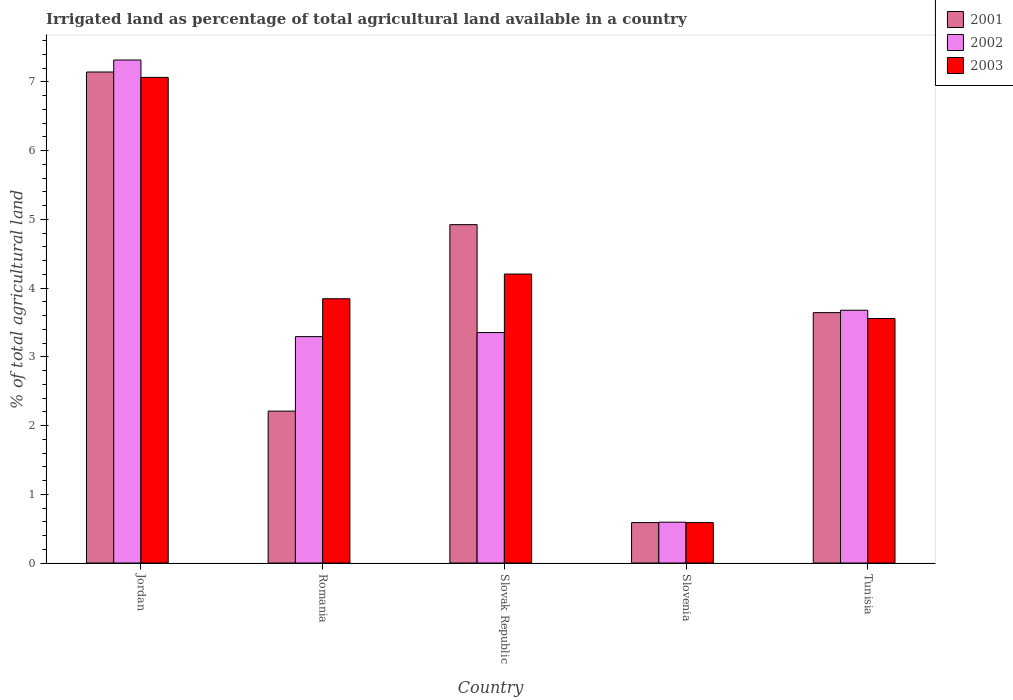How many groups of bars are there?
Keep it short and to the point. 5. How many bars are there on the 1st tick from the left?
Your answer should be compact. 3. How many bars are there on the 4th tick from the right?
Your response must be concise. 3. What is the label of the 4th group of bars from the left?
Your answer should be very brief. Slovenia. In how many cases, is the number of bars for a given country not equal to the number of legend labels?
Make the answer very short. 0. What is the percentage of irrigated land in 2003 in Slovak Republic?
Ensure brevity in your answer.  4.2. Across all countries, what is the maximum percentage of irrigated land in 2003?
Offer a terse response. 7.06. Across all countries, what is the minimum percentage of irrigated land in 2001?
Your response must be concise. 0.59. In which country was the percentage of irrigated land in 2002 maximum?
Keep it short and to the point. Jordan. In which country was the percentage of irrigated land in 2001 minimum?
Provide a succinct answer. Slovenia. What is the total percentage of irrigated land in 2001 in the graph?
Keep it short and to the point. 18.51. What is the difference between the percentage of irrigated land in 2003 in Jordan and that in Slovak Republic?
Ensure brevity in your answer.  2.86. What is the difference between the percentage of irrigated land in 2003 in Slovak Republic and the percentage of irrigated land in 2001 in Slovenia?
Keep it short and to the point. 3.62. What is the average percentage of irrigated land in 2001 per country?
Offer a very short reply. 3.7. What is the difference between the percentage of irrigated land of/in 2002 and percentage of irrigated land of/in 2001 in Slovak Republic?
Offer a terse response. -1.57. What is the ratio of the percentage of irrigated land in 2001 in Jordan to that in Tunisia?
Offer a terse response. 1.96. Is the percentage of irrigated land in 2001 in Romania less than that in Tunisia?
Make the answer very short. Yes. What is the difference between the highest and the second highest percentage of irrigated land in 2003?
Provide a succinct answer. -0.36. What is the difference between the highest and the lowest percentage of irrigated land in 2001?
Keep it short and to the point. 6.55. In how many countries, is the percentage of irrigated land in 2002 greater than the average percentage of irrigated land in 2002 taken over all countries?
Your response must be concise. 2. How many bars are there?
Offer a very short reply. 15. Are all the bars in the graph horizontal?
Provide a short and direct response. No. How many countries are there in the graph?
Provide a succinct answer. 5. What is the difference between two consecutive major ticks on the Y-axis?
Make the answer very short. 1. Does the graph contain grids?
Provide a short and direct response. No. How many legend labels are there?
Your answer should be very brief. 3. How are the legend labels stacked?
Your answer should be very brief. Vertical. What is the title of the graph?
Offer a terse response. Irrigated land as percentage of total agricultural land available in a country. Does "1966" appear as one of the legend labels in the graph?
Your answer should be very brief. No. What is the label or title of the X-axis?
Your answer should be very brief. Country. What is the label or title of the Y-axis?
Provide a short and direct response. % of total agricultural land. What is the % of total agricultural land in 2001 in Jordan?
Make the answer very short. 7.14. What is the % of total agricultural land in 2002 in Jordan?
Make the answer very short. 7.32. What is the % of total agricultural land of 2003 in Jordan?
Offer a very short reply. 7.06. What is the % of total agricultural land of 2001 in Romania?
Make the answer very short. 2.21. What is the % of total agricultural land in 2002 in Romania?
Offer a terse response. 3.29. What is the % of total agricultural land of 2003 in Romania?
Offer a very short reply. 3.84. What is the % of total agricultural land in 2001 in Slovak Republic?
Make the answer very short. 4.92. What is the % of total agricultural land in 2002 in Slovak Republic?
Keep it short and to the point. 3.35. What is the % of total agricultural land of 2003 in Slovak Republic?
Offer a very short reply. 4.2. What is the % of total agricultural land in 2001 in Slovenia?
Keep it short and to the point. 0.59. What is the % of total agricultural land of 2002 in Slovenia?
Keep it short and to the point. 0.59. What is the % of total agricultural land of 2003 in Slovenia?
Provide a short and direct response. 0.59. What is the % of total agricultural land of 2001 in Tunisia?
Ensure brevity in your answer.  3.64. What is the % of total agricultural land in 2002 in Tunisia?
Your response must be concise. 3.68. What is the % of total agricultural land in 2003 in Tunisia?
Provide a succinct answer. 3.56. Across all countries, what is the maximum % of total agricultural land of 2001?
Keep it short and to the point. 7.14. Across all countries, what is the maximum % of total agricultural land in 2002?
Offer a very short reply. 7.32. Across all countries, what is the maximum % of total agricultural land of 2003?
Give a very brief answer. 7.06. Across all countries, what is the minimum % of total agricultural land in 2001?
Your answer should be very brief. 0.59. Across all countries, what is the minimum % of total agricultural land of 2002?
Make the answer very short. 0.59. Across all countries, what is the minimum % of total agricultural land in 2003?
Offer a terse response. 0.59. What is the total % of total agricultural land of 2001 in the graph?
Keep it short and to the point. 18.51. What is the total % of total agricultural land of 2002 in the graph?
Your answer should be very brief. 18.23. What is the total % of total agricultural land of 2003 in the graph?
Offer a very short reply. 19.26. What is the difference between the % of total agricultural land of 2001 in Jordan and that in Romania?
Ensure brevity in your answer.  4.93. What is the difference between the % of total agricultural land in 2002 in Jordan and that in Romania?
Provide a succinct answer. 4.02. What is the difference between the % of total agricultural land in 2003 in Jordan and that in Romania?
Provide a succinct answer. 3.22. What is the difference between the % of total agricultural land in 2001 in Jordan and that in Slovak Republic?
Provide a short and direct response. 2.22. What is the difference between the % of total agricultural land of 2002 in Jordan and that in Slovak Republic?
Your answer should be compact. 3.96. What is the difference between the % of total agricultural land in 2003 in Jordan and that in Slovak Republic?
Provide a succinct answer. 2.86. What is the difference between the % of total agricultural land of 2001 in Jordan and that in Slovenia?
Offer a very short reply. 6.55. What is the difference between the % of total agricultural land in 2002 in Jordan and that in Slovenia?
Your response must be concise. 6.72. What is the difference between the % of total agricultural land in 2003 in Jordan and that in Slovenia?
Ensure brevity in your answer.  6.48. What is the difference between the % of total agricultural land in 2001 in Jordan and that in Tunisia?
Your answer should be very brief. 3.5. What is the difference between the % of total agricultural land of 2002 in Jordan and that in Tunisia?
Offer a terse response. 3.64. What is the difference between the % of total agricultural land in 2003 in Jordan and that in Tunisia?
Provide a short and direct response. 3.51. What is the difference between the % of total agricultural land in 2001 in Romania and that in Slovak Republic?
Make the answer very short. -2.71. What is the difference between the % of total agricultural land in 2002 in Romania and that in Slovak Republic?
Give a very brief answer. -0.06. What is the difference between the % of total agricultural land of 2003 in Romania and that in Slovak Republic?
Your answer should be compact. -0.36. What is the difference between the % of total agricultural land of 2001 in Romania and that in Slovenia?
Your response must be concise. 1.62. What is the difference between the % of total agricultural land of 2002 in Romania and that in Slovenia?
Your answer should be very brief. 2.7. What is the difference between the % of total agricultural land in 2003 in Romania and that in Slovenia?
Your answer should be very brief. 3.26. What is the difference between the % of total agricultural land in 2001 in Romania and that in Tunisia?
Make the answer very short. -1.43. What is the difference between the % of total agricultural land in 2002 in Romania and that in Tunisia?
Provide a succinct answer. -0.38. What is the difference between the % of total agricultural land in 2003 in Romania and that in Tunisia?
Make the answer very short. 0.29. What is the difference between the % of total agricultural land in 2001 in Slovak Republic and that in Slovenia?
Your answer should be compact. 4.33. What is the difference between the % of total agricultural land of 2002 in Slovak Republic and that in Slovenia?
Your answer should be compact. 2.76. What is the difference between the % of total agricultural land in 2003 in Slovak Republic and that in Slovenia?
Your answer should be very brief. 3.62. What is the difference between the % of total agricultural land of 2001 in Slovak Republic and that in Tunisia?
Ensure brevity in your answer.  1.28. What is the difference between the % of total agricultural land in 2002 in Slovak Republic and that in Tunisia?
Your response must be concise. -0.32. What is the difference between the % of total agricultural land in 2003 in Slovak Republic and that in Tunisia?
Keep it short and to the point. 0.65. What is the difference between the % of total agricultural land of 2001 in Slovenia and that in Tunisia?
Your response must be concise. -3.05. What is the difference between the % of total agricultural land of 2002 in Slovenia and that in Tunisia?
Offer a terse response. -3.08. What is the difference between the % of total agricultural land in 2003 in Slovenia and that in Tunisia?
Provide a short and direct response. -2.97. What is the difference between the % of total agricultural land in 2001 in Jordan and the % of total agricultural land in 2002 in Romania?
Provide a short and direct response. 3.85. What is the difference between the % of total agricultural land of 2001 in Jordan and the % of total agricultural land of 2003 in Romania?
Keep it short and to the point. 3.3. What is the difference between the % of total agricultural land in 2002 in Jordan and the % of total agricultural land in 2003 in Romania?
Give a very brief answer. 3.47. What is the difference between the % of total agricultural land of 2001 in Jordan and the % of total agricultural land of 2002 in Slovak Republic?
Offer a very short reply. 3.79. What is the difference between the % of total agricultural land in 2001 in Jordan and the % of total agricultural land in 2003 in Slovak Republic?
Your response must be concise. 2.94. What is the difference between the % of total agricultural land of 2002 in Jordan and the % of total agricultural land of 2003 in Slovak Republic?
Offer a very short reply. 3.11. What is the difference between the % of total agricultural land of 2001 in Jordan and the % of total agricultural land of 2002 in Slovenia?
Your answer should be compact. 6.55. What is the difference between the % of total agricultural land of 2001 in Jordan and the % of total agricultural land of 2003 in Slovenia?
Your answer should be very brief. 6.55. What is the difference between the % of total agricultural land in 2002 in Jordan and the % of total agricultural land in 2003 in Slovenia?
Your answer should be very brief. 6.73. What is the difference between the % of total agricultural land of 2001 in Jordan and the % of total agricultural land of 2002 in Tunisia?
Your response must be concise. 3.47. What is the difference between the % of total agricultural land of 2001 in Jordan and the % of total agricultural land of 2003 in Tunisia?
Offer a terse response. 3.59. What is the difference between the % of total agricultural land of 2002 in Jordan and the % of total agricultural land of 2003 in Tunisia?
Make the answer very short. 3.76. What is the difference between the % of total agricultural land of 2001 in Romania and the % of total agricultural land of 2002 in Slovak Republic?
Your response must be concise. -1.14. What is the difference between the % of total agricultural land of 2001 in Romania and the % of total agricultural land of 2003 in Slovak Republic?
Offer a terse response. -1.99. What is the difference between the % of total agricultural land in 2002 in Romania and the % of total agricultural land in 2003 in Slovak Republic?
Your answer should be very brief. -0.91. What is the difference between the % of total agricultural land in 2001 in Romania and the % of total agricultural land in 2002 in Slovenia?
Provide a short and direct response. 1.62. What is the difference between the % of total agricultural land of 2001 in Romania and the % of total agricultural land of 2003 in Slovenia?
Provide a succinct answer. 1.62. What is the difference between the % of total agricultural land in 2002 in Romania and the % of total agricultural land in 2003 in Slovenia?
Your answer should be very brief. 2.71. What is the difference between the % of total agricultural land in 2001 in Romania and the % of total agricultural land in 2002 in Tunisia?
Provide a short and direct response. -1.47. What is the difference between the % of total agricultural land of 2001 in Romania and the % of total agricultural land of 2003 in Tunisia?
Offer a terse response. -1.35. What is the difference between the % of total agricultural land of 2002 in Romania and the % of total agricultural land of 2003 in Tunisia?
Offer a very short reply. -0.26. What is the difference between the % of total agricultural land in 2001 in Slovak Republic and the % of total agricultural land in 2002 in Slovenia?
Provide a short and direct response. 4.33. What is the difference between the % of total agricultural land in 2001 in Slovak Republic and the % of total agricultural land in 2003 in Slovenia?
Your answer should be compact. 4.33. What is the difference between the % of total agricultural land in 2002 in Slovak Republic and the % of total agricultural land in 2003 in Slovenia?
Keep it short and to the point. 2.76. What is the difference between the % of total agricultural land in 2001 in Slovak Republic and the % of total agricultural land in 2002 in Tunisia?
Give a very brief answer. 1.25. What is the difference between the % of total agricultural land in 2001 in Slovak Republic and the % of total agricultural land in 2003 in Tunisia?
Your answer should be very brief. 1.37. What is the difference between the % of total agricultural land in 2002 in Slovak Republic and the % of total agricultural land in 2003 in Tunisia?
Your answer should be compact. -0.2. What is the difference between the % of total agricultural land of 2001 in Slovenia and the % of total agricultural land of 2002 in Tunisia?
Offer a very short reply. -3.09. What is the difference between the % of total agricultural land in 2001 in Slovenia and the % of total agricultural land in 2003 in Tunisia?
Keep it short and to the point. -2.97. What is the difference between the % of total agricultural land in 2002 in Slovenia and the % of total agricultural land in 2003 in Tunisia?
Ensure brevity in your answer.  -2.96. What is the average % of total agricultural land of 2001 per country?
Your answer should be compact. 3.7. What is the average % of total agricultural land in 2002 per country?
Your answer should be compact. 3.65. What is the average % of total agricultural land of 2003 per country?
Offer a terse response. 3.85. What is the difference between the % of total agricultural land in 2001 and % of total agricultural land in 2002 in Jordan?
Provide a short and direct response. -0.17. What is the difference between the % of total agricultural land of 2001 and % of total agricultural land of 2003 in Jordan?
Ensure brevity in your answer.  0.08. What is the difference between the % of total agricultural land of 2002 and % of total agricultural land of 2003 in Jordan?
Offer a terse response. 0.25. What is the difference between the % of total agricultural land of 2001 and % of total agricultural land of 2002 in Romania?
Provide a succinct answer. -1.08. What is the difference between the % of total agricultural land of 2001 and % of total agricultural land of 2003 in Romania?
Give a very brief answer. -1.63. What is the difference between the % of total agricultural land of 2002 and % of total agricultural land of 2003 in Romania?
Offer a terse response. -0.55. What is the difference between the % of total agricultural land of 2001 and % of total agricultural land of 2002 in Slovak Republic?
Provide a short and direct response. 1.57. What is the difference between the % of total agricultural land of 2001 and % of total agricultural land of 2003 in Slovak Republic?
Give a very brief answer. 0.72. What is the difference between the % of total agricultural land of 2002 and % of total agricultural land of 2003 in Slovak Republic?
Your answer should be compact. -0.85. What is the difference between the % of total agricultural land of 2001 and % of total agricultural land of 2002 in Slovenia?
Ensure brevity in your answer.  -0.01. What is the difference between the % of total agricultural land in 2002 and % of total agricultural land in 2003 in Slovenia?
Your response must be concise. 0.01. What is the difference between the % of total agricultural land in 2001 and % of total agricultural land in 2002 in Tunisia?
Provide a succinct answer. -0.03. What is the difference between the % of total agricultural land of 2001 and % of total agricultural land of 2003 in Tunisia?
Offer a terse response. 0.09. What is the difference between the % of total agricultural land in 2002 and % of total agricultural land in 2003 in Tunisia?
Your answer should be compact. 0.12. What is the ratio of the % of total agricultural land of 2001 in Jordan to that in Romania?
Ensure brevity in your answer.  3.23. What is the ratio of the % of total agricultural land of 2002 in Jordan to that in Romania?
Make the answer very short. 2.22. What is the ratio of the % of total agricultural land of 2003 in Jordan to that in Romania?
Give a very brief answer. 1.84. What is the ratio of the % of total agricultural land in 2001 in Jordan to that in Slovak Republic?
Your response must be concise. 1.45. What is the ratio of the % of total agricultural land in 2002 in Jordan to that in Slovak Republic?
Ensure brevity in your answer.  2.18. What is the ratio of the % of total agricultural land in 2003 in Jordan to that in Slovak Republic?
Make the answer very short. 1.68. What is the ratio of the % of total agricultural land of 2001 in Jordan to that in Slovenia?
Your answer should be very brief. 12.14. What is the ratio of the % of total agricultural land of 2002 in Jordan to that in Slovenia?
Provide a succinct answer. 12.32. What is the ratio of the % of total agricultural land of 2003 in Jordan to that in Slovenia?
Ensure brevity in your answer.  12.01. What is the ratio of the % of total agricultural land of 2001 in Jordan to that in Tunisia?
Offer a very short reply. 1.96. What is the ratio of the % of total agricultural land of 2002 in Jordan to that in Tunisia?
Provide a short and direct response. 1.99. What is the ratio of the % of total agricultural land of 2003 in Jordan to that in Tunisia?
Offer a very short reply. 1.99. What is the ratio of the % of total agricultural land of 2001 in Romania to that in Slovak Republic?
Your response must be concise. 0.45. What is the ratio of the % of total agricultural land in 2002 in Romania to that in Slovak Republic?
Keep it short and to the point. 0.98. What is the ratio of the % of total agricultural land of 2003 in Romania to that in Slovak Republic?
Give a very brief answer. 0.91. What is the ratio of the % of total agricultural land of 2001 in Romania to that in Slovenia?
Make the answer very short. 3.76. What is the ratio of the % of total agricultural land of 2002 in Romania to that in Slovenia?
Ensure brevity in your answer.  5.54. What is the ratio of the % of total agricultural land of 2003 in Romania to that in Slovenia?
Your response must be concise. 6.54. What is the ratio of the % of total agricultural land in 2001 in Romania to that in Tunisia?
Make the answer very short. 0.61. What is the ratio of the % of total agricultural land in 2002 in Romania to that in Tunisia?
Your answer should be very brief. 0.9. What is the ratio of the % of total agricultural land of 2003 in Romania to that in Tunisia?
Give a very brief answer. 1.08. What is the ratio of the % of total agricultural land in 2001 in Slovak Republic to that in Slovenia?
Offer a very short reply. 8.37. What is the ratio of the % of total agricultural land in 2002 in Slovak Republic to that in Slovenia?
Your response must be concise. 5.64. What is the ratio of the % of total agricultural land in 2003 in Slovak Republic to that in Slovenia?
Give a very brief answer. 7.15. What is the ratio of the % of total agricultural land of 2001 in Slovak Republic to that in Tunisia?
Provide a succinct answer. 1.35. What is the ratio of the % of total agricultural land in 2002 in Slovak Republic to that in Tunisia?
Provide a short and direct response. 0.91. What is the ratio of the % of total agricultural land in 2003 in Slovak Republic to that in Tunisia?
Your answer should be very brief. 1.18. What is the ratio of the % of total agricultural land in 2001 in Slovenia to that in Tunisia?
Offer a very short reply. 0.16. What is the ratio of the % of total agricultural land of 2002 in Slovenia to that in Tunisia?
Keep it short and to the point. 0.16. What is the ratio of the % of total agricultural land of 2003 in Slovenia to that in Tunisia?
Give a very brief answer. 0.17. What is the difference between the highest and the second highest % of total agricultural land of 2001?
Provide a succinct answer. 2.22. What is the difference between the highest and the second highest % of total agricultural land of 2002?
Your answer should be compact. 3.64. What is the difference between the highest and the second highest % of total agricultural land of 2003?
Make the answer very short. 2.86. What is the difference between the highest and the lowest % of total agricultural land in 2001?
Your answer should be compact. 6.55. What is the difference between the highest and the lowest % of total agricultural land of 2002?
Provide a short and direct response. 6.72. What is the difference between the highest and the lowest % of total agricultural land of 2003?
Your response must be concise. 6.48. 